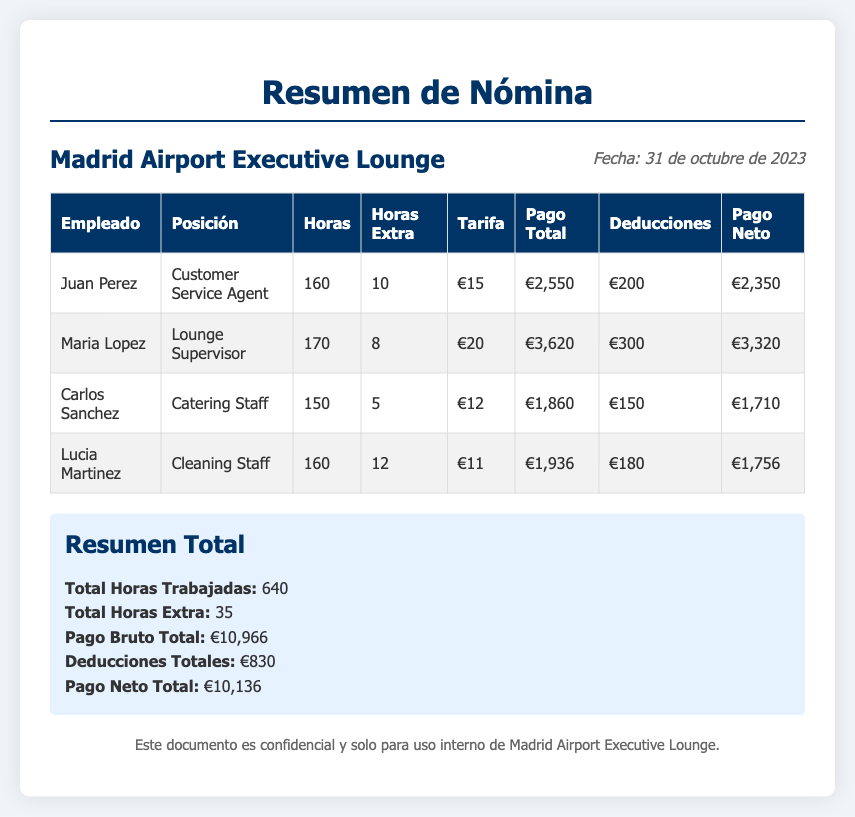What is the total number of employees listed? The document lists four employees: Juan Perez, Maria Lopez, Carlos Sanchez, and Lucia Martinez.
Answer: 4 What is the position of Maria Lopez? The position listed for Maria Lopez in the document is Lounge Supervisor.
Answer: Lounge Supervisor How many hours did Juan Perez work? Juan Perez's total hours worked in the document is specified as 160 hours.
Answer: 160 What is the total amount of deductions? The total deductions for all employees combined, as noted in the summary, is €830.
Answer: €830 Who worked the most overtime hours? The employee with the most overtime hours is Lucia Martinez, who worked 12 hours extra.
Answer: Lucia Martinez What is the total payment (net) for Carlos Sanchez? The net payment for Carlos Sanchez, after deductions, is stated as €1,710.
Answer: €1,710 What is the total gross payment for all employees combined? The total gross payment for all employees is calculated to be €10,966 as per the summary.
Answer: €10,966 How many total hours were worked by all employees? The document provides a total of 640 hours worked by all employees as noted in the summary.
Answer: 640 What was the hourly rate of Lucia Martinez? Lucia Martinez's hourly rate, according to the document, is €11.
Answer: €11 